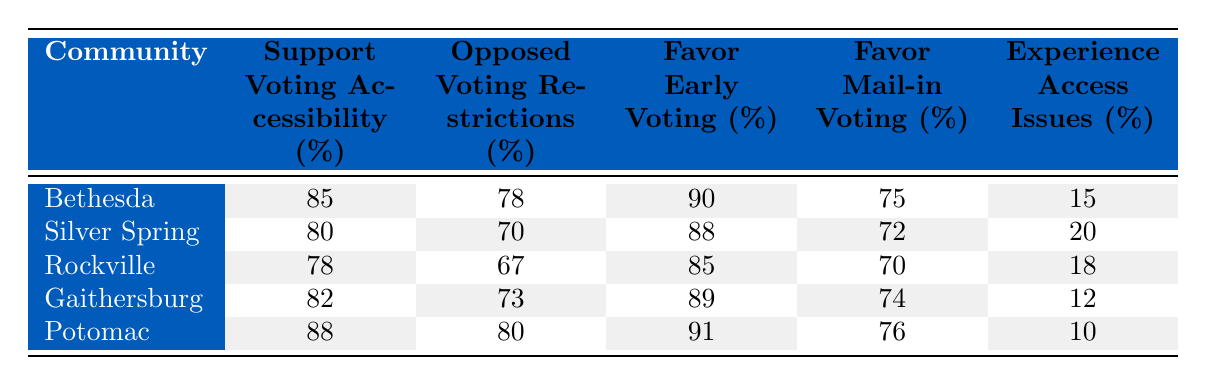What is the percentage of residents in Bethesda that support voting accessibility? According to the table, the percentage of residents in Bethesda who support voting accessibility is clearly marked, which is 85%.
Answer: 85% What percentage of residents in Gaithersburg oppose voting restrictions? The table shows that 73% of residents in Gaithersburg are opposed to voting restrictions.
Answer: 73% Which community has the highest percentage of support for mail-in voting? By comparing the percentages for mail-in voting across all communities, Potomac is identified as having the highest percentage at 76%.
Answer: 76% Calculate the average percentage of support for early voting across all communities. The percentages for early voting are 90, 88, 85, 89, and 91. First, sum these values (90 + 88 + 85 + 89 + 91 = 443), then divide by the number of communities (443 / 5 = 88.6). Therefore, the average is 88.6%.
Answer: 88.6% Is it true that more than 80% of the residents in Silver Spring favor early voting? In the table, the percentage of residents in Silver Spring who favor early voting is noted as 88%, which is indeed more than 80%.
Answer: Yes Which community has the lowest percentage of residents experiencing access issues? The table indicates that Potomac has the lowest percentage of residents experiencing access issues at 10%.
Answer: 10% What is the difference between the percentage of residents who favor early voting in Bethesda and those in Rockville? By looking at the table, Bethesda has 90% in favor of early voting while Rockville has 85%. The difference is calculated as 90 - 85 = 5%.
Answer: 5% Do a majority of residents in all communities support voting accessibility? Checking the data for each community, all show percentages of support that are above 50%, thus confirming that a majority do support voting accessibility.
Answer: Yes What is the community with the highest percentage of residents that experience access issues? Comparing the access issue percentages, Silver Spring at 20% has the highest among the communities listed.
Answer: 20% 